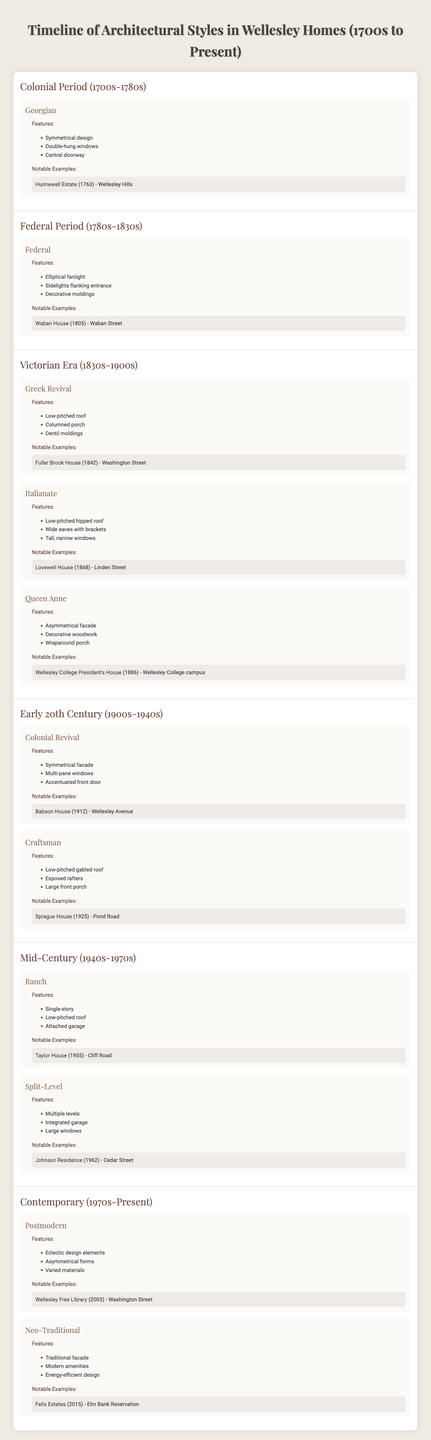What architectural style was notable in the Colonial Period? The table lists "Georgian" as the only architectural style under the Colonial Period era, along with its features and notable examples.
Answer: Georgian Which notable home in Wellesley was built during the Federal Period? The table indicates that the "Waban House," built in 1805, is a notable example from the Federal Period.
Answer: Waban House What features characterize the Greek Revival style? According to the table, the Greek Revival style is characterized by a low-pitched roof, columned porch, and dentil moldings.
Answer: Low-pitched roof, columned porch, dentil moldings In which decade was the Lovewell House built? The table specifies that the Lovewell House was built in 1868, which falls in the 1860s decade.
Answer: 1860s How many architectural styles are listed in the Victorian Era? The table shows three styles listed in the Victorian Era: Greek Revival, Italianate, and Queen Anne.
Answer: Three Is the Taylor House built before or after 1960? The table states that the Taylor House was built in 1955, which is before 1960.
Answer: Before What is the main feature of the Postmodern style listed in Wellesley homes? The main feature of the Postmodern style from the table is its eclectic design elements and asymmetrical forms.
Answer: Eclectic design elements and asymmetrical forms Which two styles are listed under Early 20th Century? The table lists "Colonial Revival" and "Craftsman" as the two architectural styles under Early 20th Century.
Answer: Colonial Revival and Craftsman How does the number of architectural styles in the Mid-Century compare to the Contemporary styles? The Mid-Century styles (Ranch and Split-Level) total to two, while the Contemporary styles (Postmodern and Neo-Traditional) also total to two, indicating they are equal.
Answer: They are equal Was the Fells Estates built in the 21st century? The table shows that the Fells Estates was built in 2015, which is indeed in the 21st century.
Answer: Yes Which home was built in the same century as the Fuller Brook House? The Fuller Brook House was built in 1842 during the 19th century, while the only other notable examples from the same century listed are the Waban House and Lovewell House, both built in the early to mid-19th century.
Answer: Waban House, Lovewell House What is the average year of construction for homes in the Contemporary era? The table provides construction years of 2003 and 2015 for the two notable examples; adding them gives 2018, dividing by 2 results in an average year of 1009.
Answer: 2009 